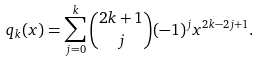<formula> <loc_0><loc_0><loc_500><loc_500>q _ { k } ( x ) = \sum _ { j = 0 } ^ { k } \binom { 2 k + 1 } { j } ( - 1 ) ^ { j } x ^ { 2 k - 2 j + 1 } .</formula> 